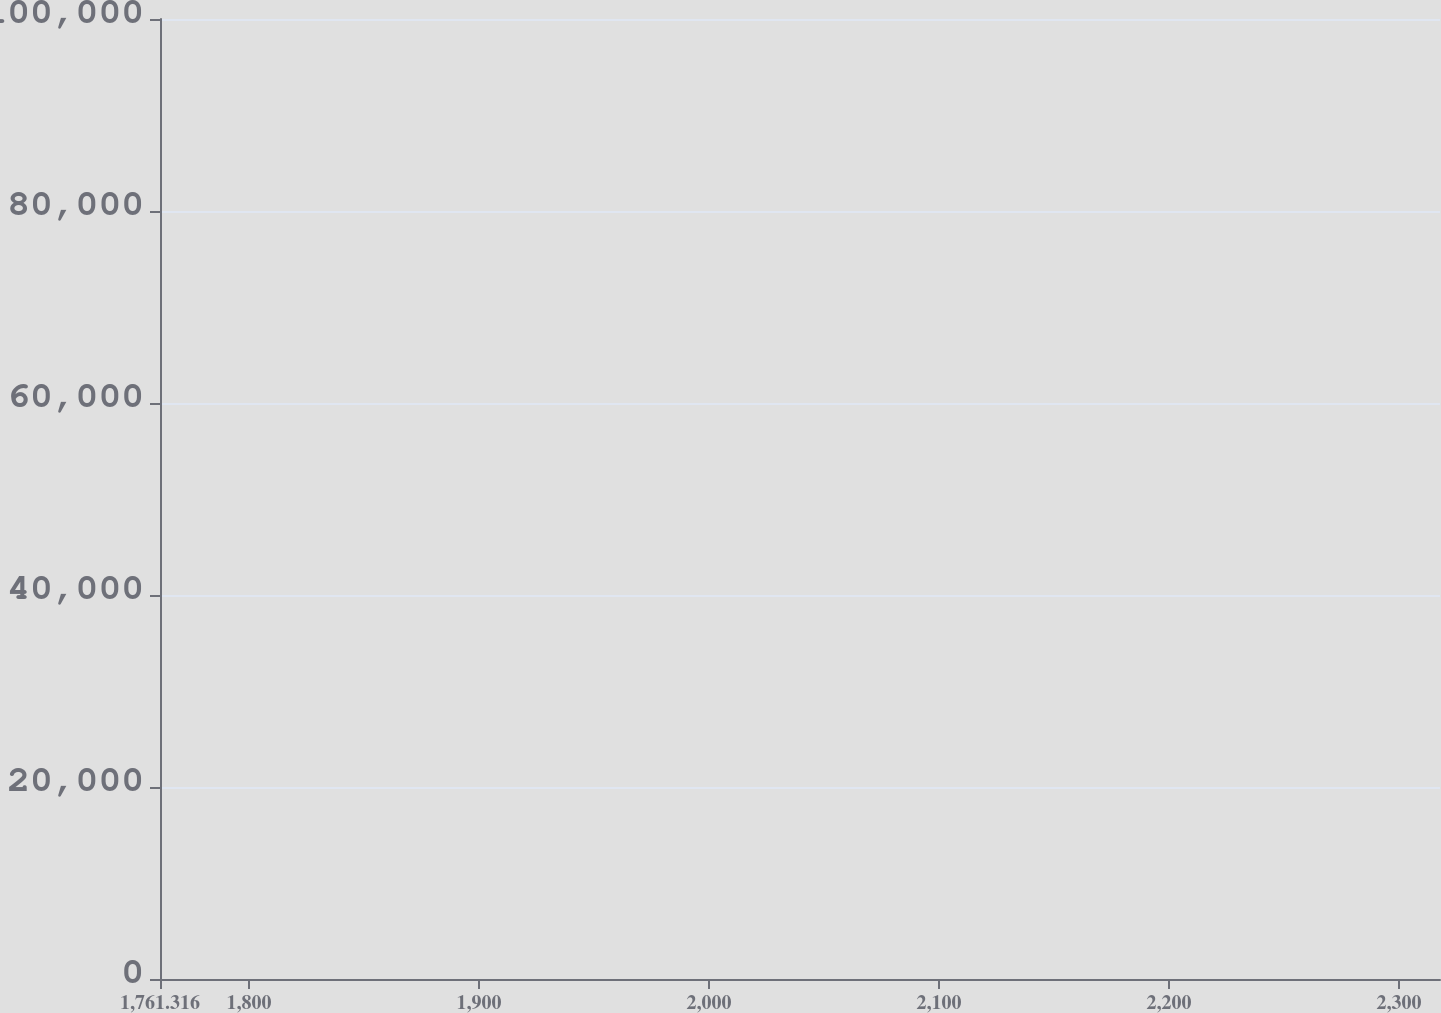Convert chart to OTSL. <chart><loc_0><loc_0><loc_500><loc_500><line_chart><ecel><fcel>Capital  Leases<fcel>Operating  Leases<nl><fcel>1816.97<fcel>81497.8<fcel>6354.83<nl><fcel>1935.13<fcel>68900.1<fcel>7469.33<nl><fcel>1988.03<fcel>77298.6<fcel>3941.83<nl><fcel>2320.61<fcel>73099.3<fcel>4848.25<nl><fcel>2373.51<fcel>34161.2<fcel>5201<nl></chart> 